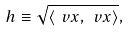Convert formula to latex. <formula><loc_0><loc_0><loc_500><loc_500>h \equiv \sqrt { \left < \ v x , \ v x \right > } ,</formula> 